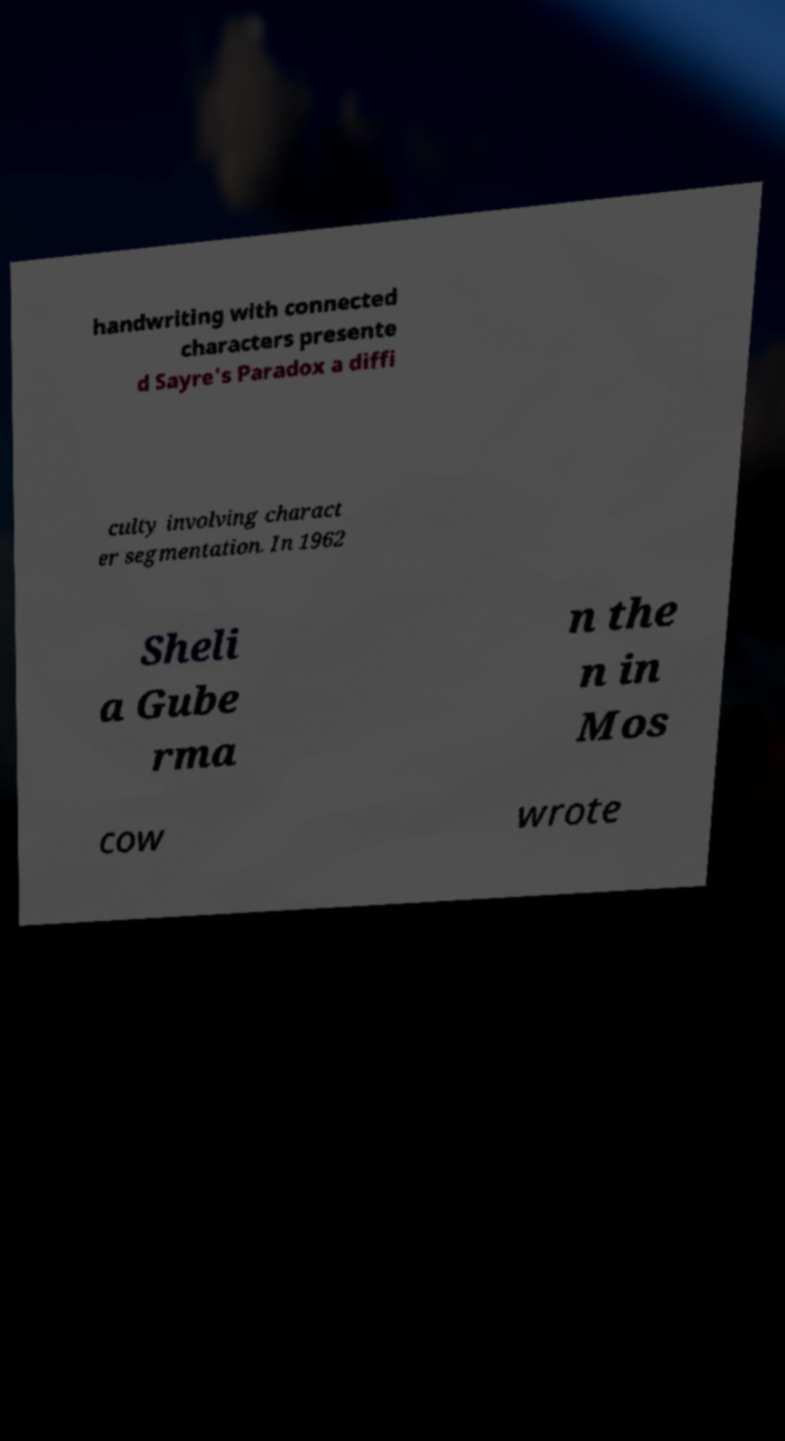There's text embedded in this image that I need extracted. Can you transcribe it verbatim? handwriting with connected characters presente d Sayre's Paradox a diffi culty involving charact er segmentation. In 1962 Sheli a Gube rma n the n in Mos cow wrote 